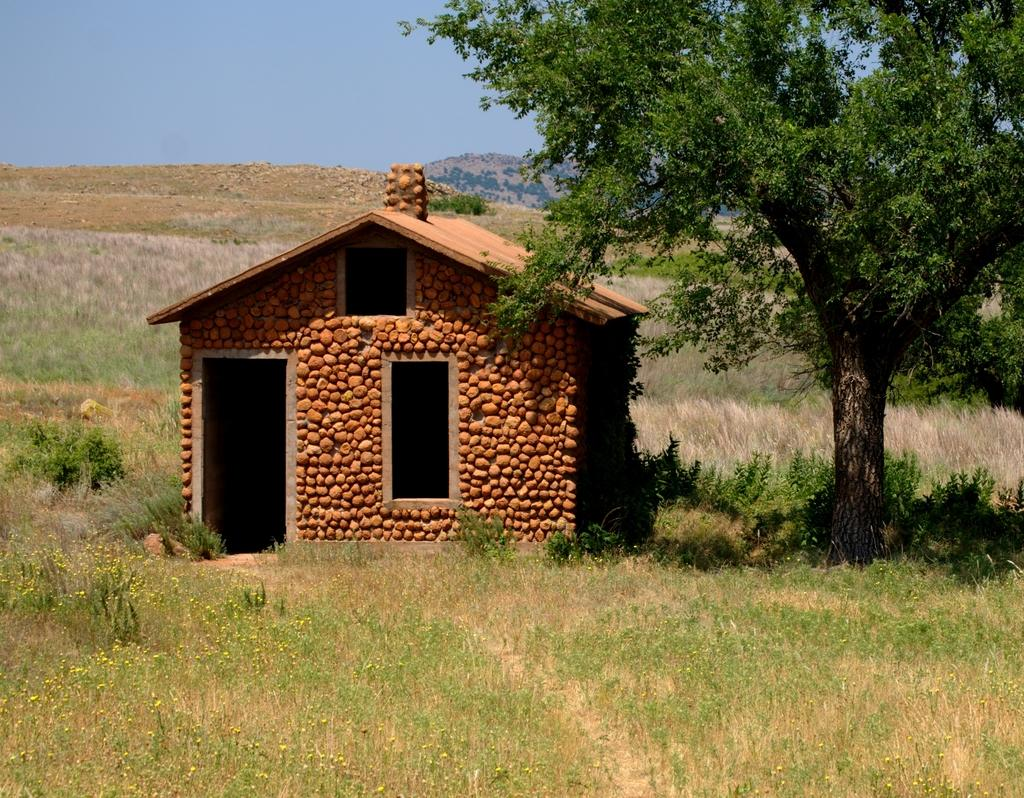What is the main structure in the middle of the image? There is a house in the middle of the image. What type of vegetation is on the right side of the image? There is a tree on the right side of the image. What covers the ground in the image? There is grass on the ground. What can be seen in the background of the image? The sky is visible in the background of the image. What type of stocking is hanging from the tree in the image? There is no stocking hanging from the tree in the image. How many times has the month changed since the image was taken? The provided facts do not give any information about the time or date the image was taken, so it is impossible to determine how many times the month has changed. 